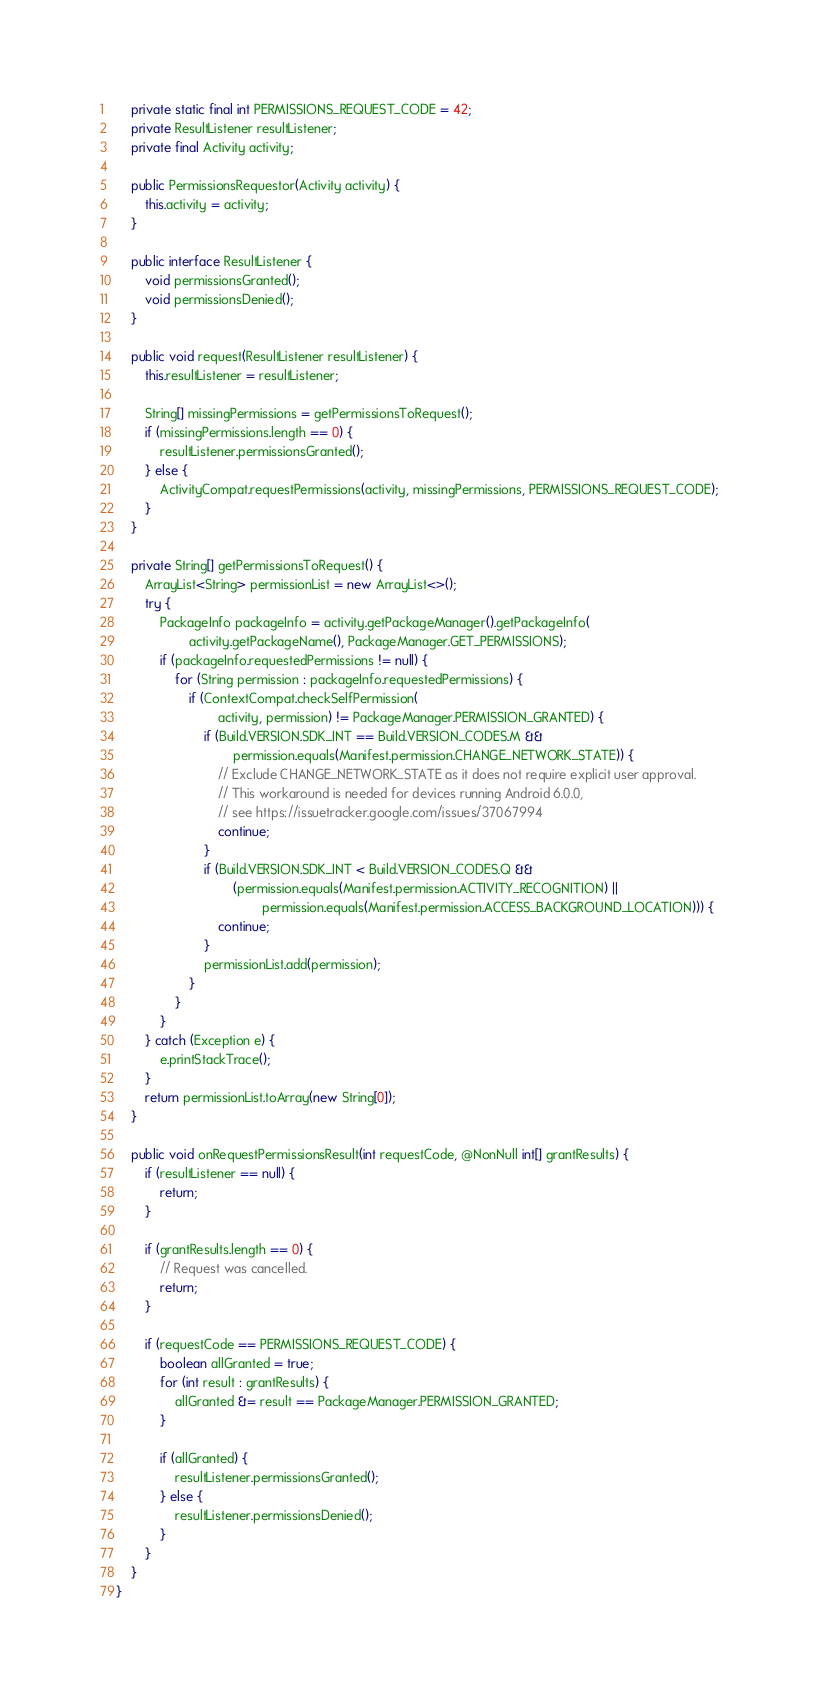<code> <loc_0><loc_0><loc_500><loc_500><_Java_>
    private static final int PERMISSIONS_REQUEST_CODE = 42;
    private ResultListener resultListener;
    private final Activity activity;

    public PermissionsRequestor(Activity activity) {
        this.activity = activity;
    }

    public interface ResultListener {
        void permissionsGranted();
        void permissionsDenied();
    }

    public void request(ResultListener resultListener) {
        this.resultListener = resultListener;

        String[] missingPermissions = getPermissionsToRequest();
        if (missingPermissions.length == 0) {
            resultListener.permissionsGranted();
        } else {
            ActivityCompat.requestPermissions(activity, missingPermissions, PERMISSIONS_REQUEST_CODE);
        }
    }

    private String[] getPermissionsToRequest() {
        ArrayList<String> permissionList = new ArrayList<>();
        try {
            PackageInfo packageInfo = activity.getPackageManager().getPackageInfo(
                    activity.getPackageName(), PackageManager.GET_PERMISSIONS);
            if (packageInfo.requestedPermissions != null) {
                for (String permission : packageInfo.requestedPermissions) {
                    if (ContextCompat.checkSelfPermission(
                            activity, permission) != PackageManager.PERMISSION_GRANTED) {
                        if (Build.VERSION.SDK_INT == Build.VERSION_CODES.M &&
                                permission.equals(Manifest.permission.CHANGE_NETWORK_STATE)) {
                            // Exclude CHANGE_NETWORK_STATE as it does not require explicit user approval.
                            // This workaround is needed for devices running Android 6.0.0,
                            // see https://issuetracker.google.com/issues/37067994
                            continue;
                        }
                        if (Build.VERSION.SDK_INT < Build.VERSION_CODES.Q &&
                                (permission.equals(Manifest.permission.ACTIVITY_RECOGNITION) ||
                                        permission.equals(Manifest.permission.ACCESS_BACKGROUND_LOCATION))) {
                            continue;
                        }
                        permissionList.add(permission);
                    }
                }
            }
        } catch (Exception e) {
            e.printStackTrace();
        }
        return permissionList.toArray(new String[0]);
    }

    public void onRequestPermissionsResult(int requestCode, @NonNull int[] grantResults) {
        if (resultListener == null) {
            return;
        }

        if (grantResults.length == 0) {
            // Request was cancelled.
            return;
        }

        if (requestCode == PERMISSIONS_REQUEST_CODE) {
            boolean allGranted = true;
            for (int result : grantResults) {
                allGranted &= result == PackageManager.PERMISSION_GRANTED;
            }

            if (allGranted) {
                resultListener.permissionsGranted();
            } else {
                resultListener.permissionsDenied();
            }
        }
    }
}
</code> 